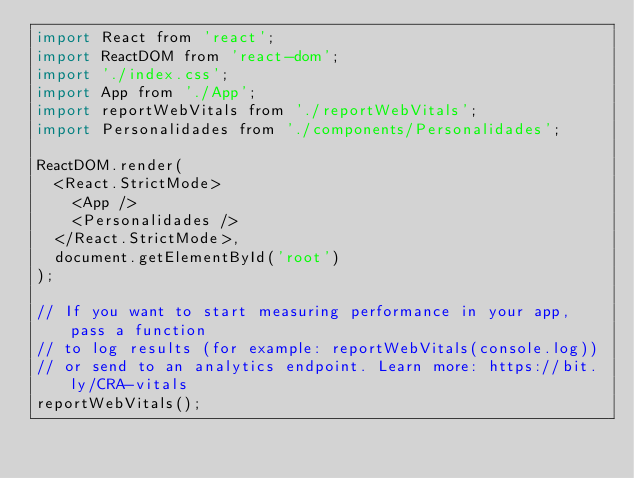Convert code to text. <code><loc_0><loc_0><loc_500><loc_500><_JavaScript_>import React from 'react';
import ReactDOM from 'react-dom';
import './index.css';
import App from './App';
import reportWebVitals from './reportWebVitals';
import Personalidades from './components/Personalidades';

ReactDOM.render(
  <React.StrictMode>
    <App />
    <Personalidades />
  </React.StrictMode>,
  document.getElementById('root')
);

// If you want to start measuring performance in your app, pass a function
// to log results (for example: reportWebVitals(console.log))
// or send to an analytics endpoint. Learn more: https://bit.ly/CRA-vitals
reportWebVitals();
</code> 